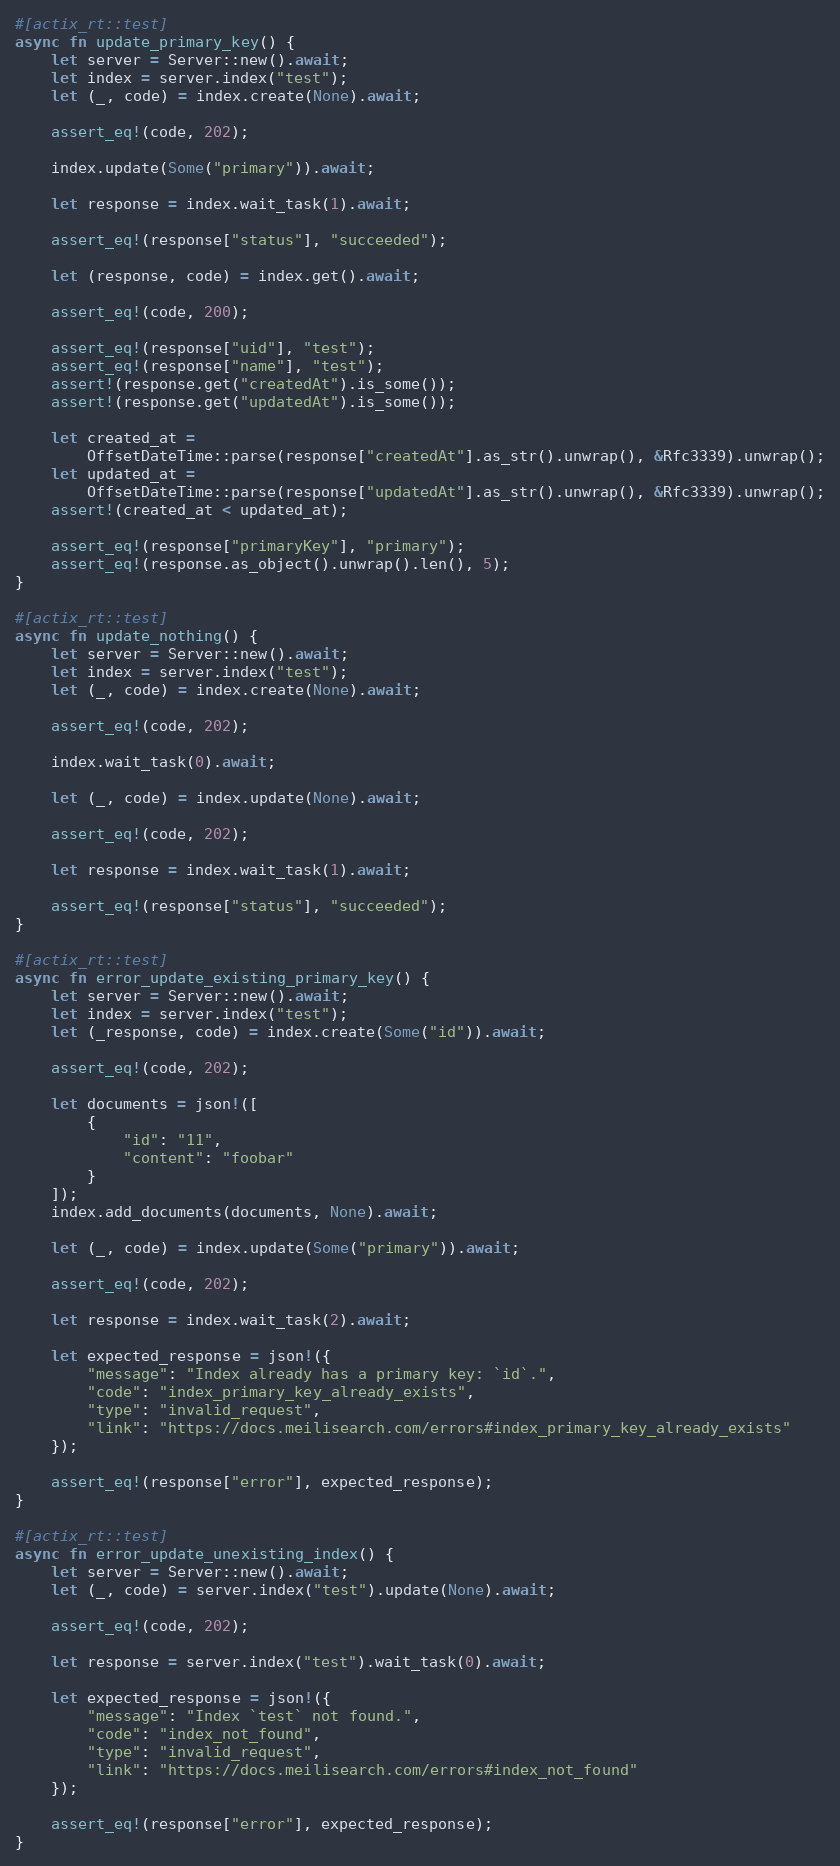Convert code to text. <code><loc_0><loc_0><loc_500><loc_500><_Rust_>
#[actix_rt::test]
async fn update_primary_key() {
    let server = Server::new().await;
    let index = server.index("test");
    let (_, code) = index.create(None).await;

    assert_eq!(code, 202);

    index.update(Some("primary")).await;

    let response = index.wait_task(1).await;

    assert_eq!(response["status"], "succeeded");

    let (response, code) = index.get().await;

    assert_eq!(code, 200);

    assert_eq!(response["uid"], "test");
    assert_eq!(response["name"], "test");
    assert!(response.get("createdAt").is_some());
    assert!(response.get("updatedAt").is_some());

    let created_at =
        OffsetDateTime::parse(response["createdAt"].as_str().unwrap(), &Rfc3339).unwrap();
    let updated_at =
        OffsetDateTime::parse(response["updatedAt"].as_str().unwrap(), &Rfc3339).unwrap();
    assert!(created_at < updated_at);

    assert_eq!(response["primaryKey"], "primary");
    assert_eq!(response.as_object().unwrap().len(), 5);
}

#[actix_rt::test]
async fn update_nothing() {
    let server = Server::new().await;
    let index = server.index("test");
    let (_, code) = index.create(None).await;

    assert_eq!(code, 202);

    index.wait_task(0).await;

    let (_, code) = index.update(None).await;

    assert_eq!(code, 202);

    let response = index.wait_task(1).await;

    assert_eq!(response["status"], "succeeded");
}

#[actix_rt::test]
async fn error_update_existing_primary_key() {
    let server = Server::new().await;
    let index = server.index("test");
    let (_response, code) = index.create(Some("id")).await;

    assert_eq!(code, 202);

    let documents = json!([
        {
            "id": "11",
            "content": "foobar"
        }
    ]);
    index.add_documents(documents, None).await;

    let (_, code) = index.update(Some("primary")).await;

    assert_eq!(code, 202);

    let response = index.wait_task(2).await;

    let expected_response = json!({
        "message": "Index already has a primary key: `id`.",
        "code": "index_primary_key_already_exists",
        "type": "invalid_request",
        "link": "https://docs.meilisearch.com/errors#index_primary_key_already_exists"
    });

    assert_eq!(response["error"], expected_response);
}

#[actix_rt::test]
async fn error_update_unexisting_index() {
    let server = Server::new().await;
    let (_, code) = server.index("test").update(None).await;

    assert_eq!(code, 202);

    let response = server.index("test").wait_task(0).await;

    let expected_response = json!({
        "message": "Index `test` not found.",
        "code": "index_not_found",
        "type": "invalid_request",
        "link": "https://docs.meilisearch.com/errors#index_not_found"
    });

    assert_eq!(response["error"], expected_response);
}
</code> 